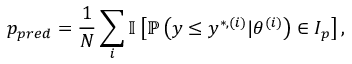<formula> <loc_0><loc_0><loc_500><loc_500>p _ { p r e d } = \frac { 1 } { N } \sum _ { i } \mathbb { I } \left [ \mathbb { P } \left ( y \leq y ^ { * , ( i ) } | \theta ^ { ( i ) } \right ) \in I _ { p } \right ] ,</formula> 